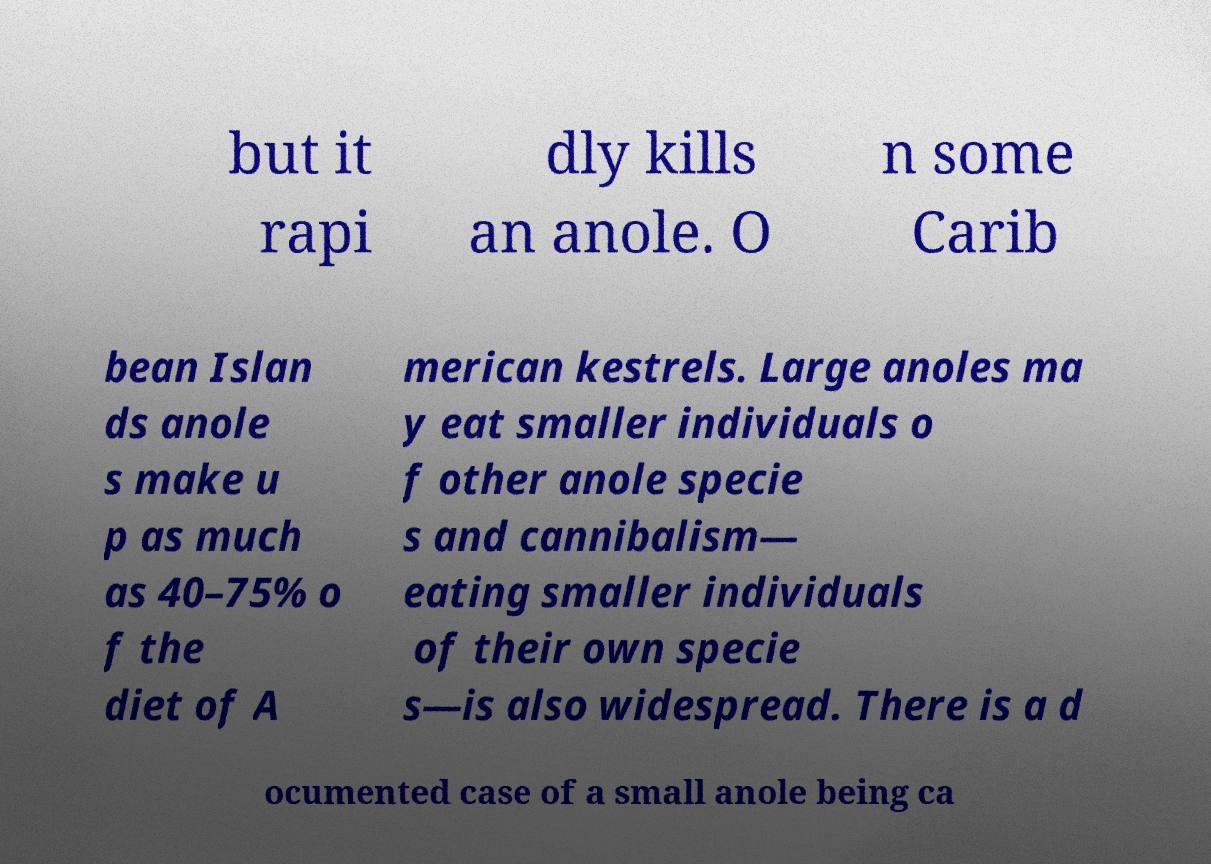Can you accurately transcribe the text from the provided image for me? but it rapi dly kills an anole. O n some Carib bean Islan ds anole s make u p as much as 40–75% o f the diet of A merican kestrels. Large anoles ma y eat smaller individuals o f other anole specie s and cannibalism— eating smaller individuals of their own specie s—is also widespread. There is a d ocumented case of a small anole being ca 